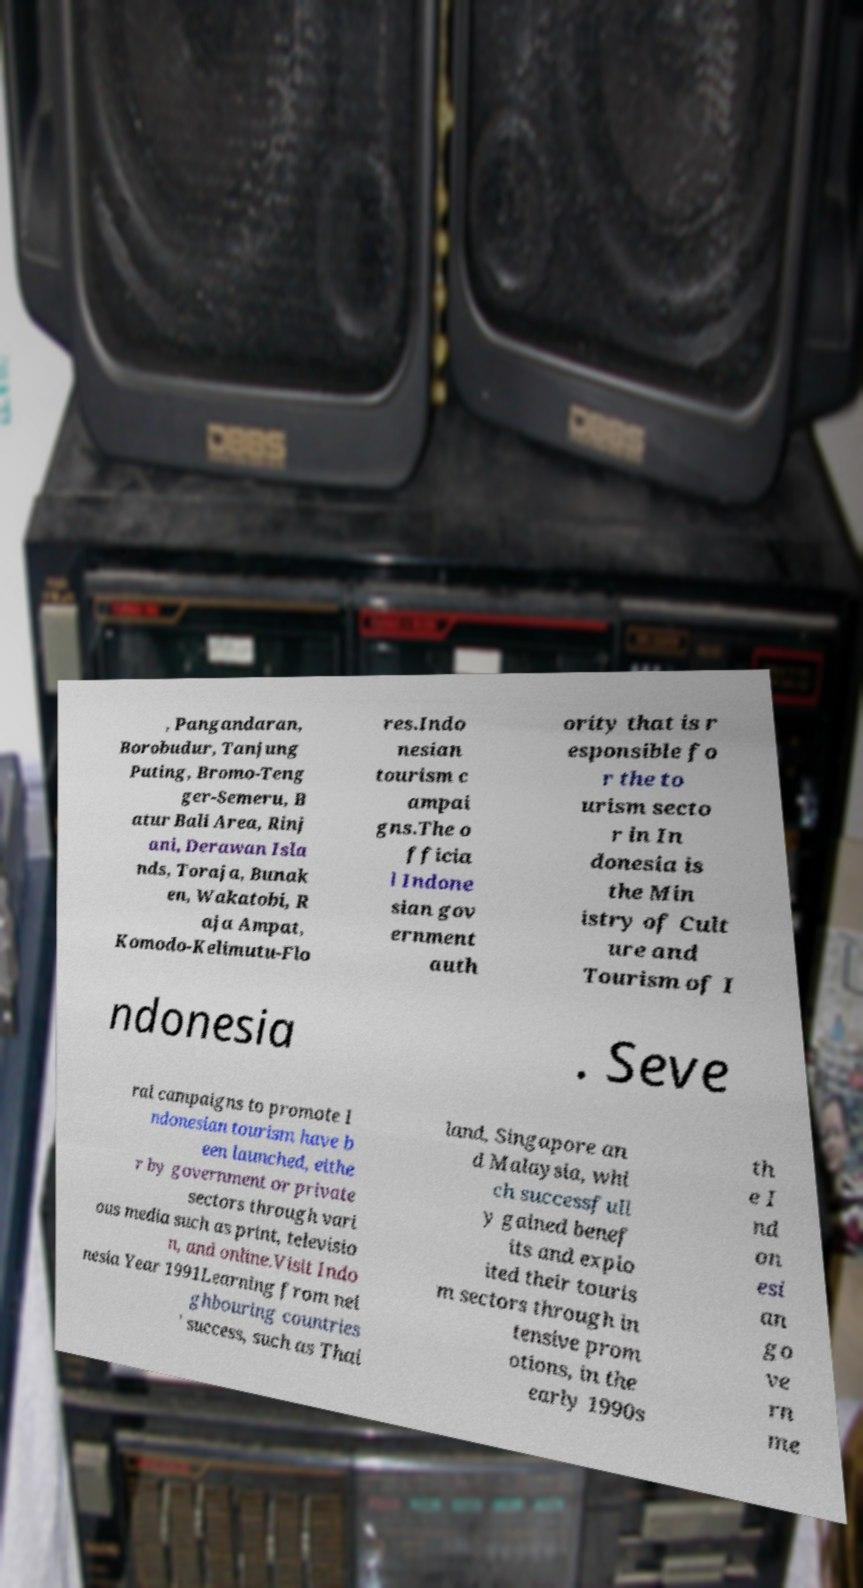Can you accurately transcribe the text from the provided image for me? , Pangandaran, Borobudur, Tanjung Puting, Bromo-Teng ger-Semeru, B atur Bali Area, Rinj ani, Derawan Isla nds, Toraja, Bunak en, Wakatobi, R aja Ampat, Komodo-Kelimutu-Flo res.Indo nesian tourism c ampai gns.The o fficia l Indone sian gov ernment auth ority that is r esponsible fo r the to urism secto r in In donesia is the Min istry of Cult ure and Tourism of I ndonesia . Seve ral campaigns to promote I ndonesian tourism have b een launched, eithe r by government or private sectors through vari ous media such as print, televisio n, and online.Visit Indo nesia Year 1991Learning from nei ghbouring countries ' success, such as Thai land, Singapore an d Malaysia, whi ch successfull y gained benef its and explo ited their touris m sectors through in tensive prom otions, in the early 1990s th e I nd on esi an go ve rn me 